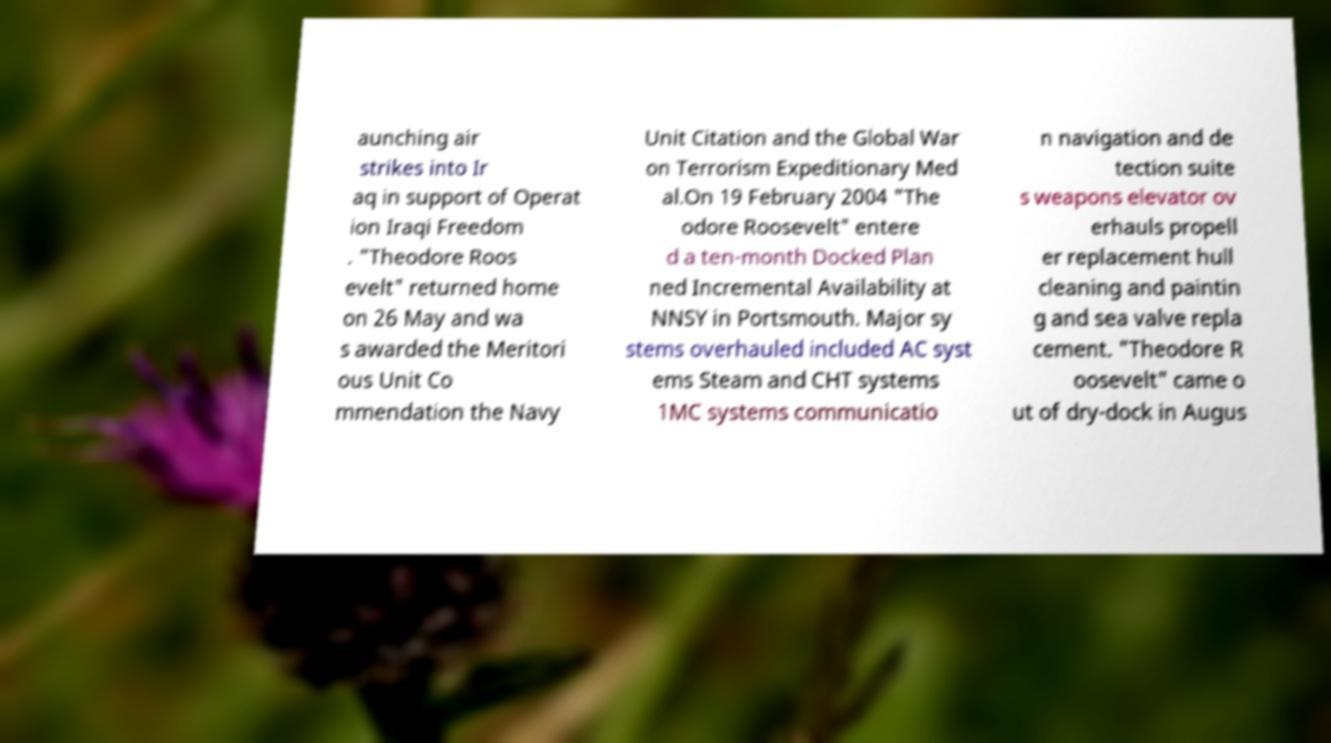Can you accurately transcribe the text from the provided image for me? aunching air strikes into Ir aq in support of Operat ion Iraqi Freedom . "Theodore Roos evelt" returned home on 26 May and wa s awarded the Meritori ous Unit Co mmendation the Navy Unit Citation and the Global War on Terrorism Expeditionary Med al.On 19 February 2004 "The odore Roosevelt" entere d a ten-month Docked Plan ned Incremental Availability at NNSY in Portsmouth. Major sy stems overhauled included AC syst ems Steam and CHT systems 1MC systems communicatio n navigation and de tection suite s weapons elevator ov erhauls propell er replacement hull cleaning and paintin g and sea valve repla cement. "Theodore R oosevelt" came o ut of dry-dock in Augus 